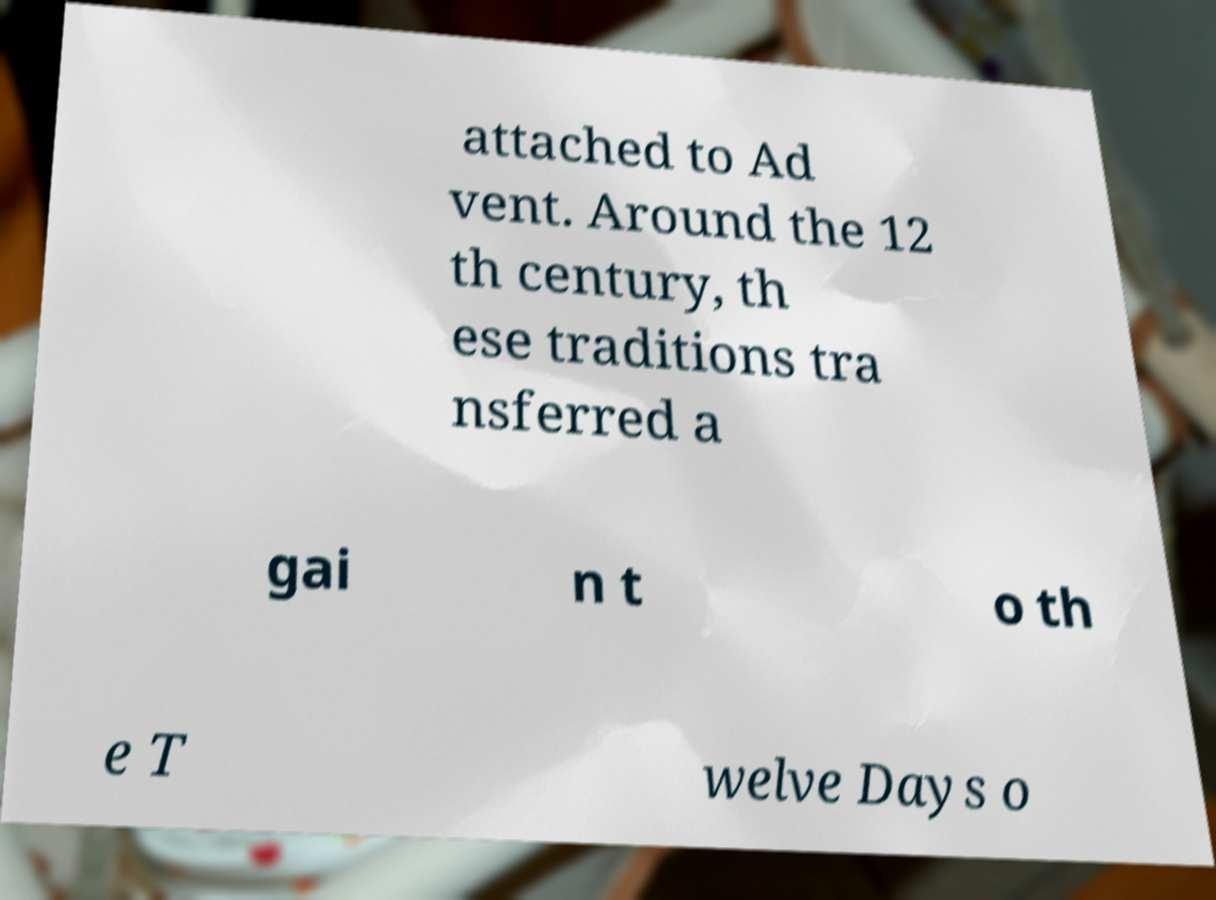Can you accurately transcribe the text from the provided image for me? attached to Ad vent. Around the 12 th century, th ese traditions tra nsferred a gai n t o th e T welve Days o 